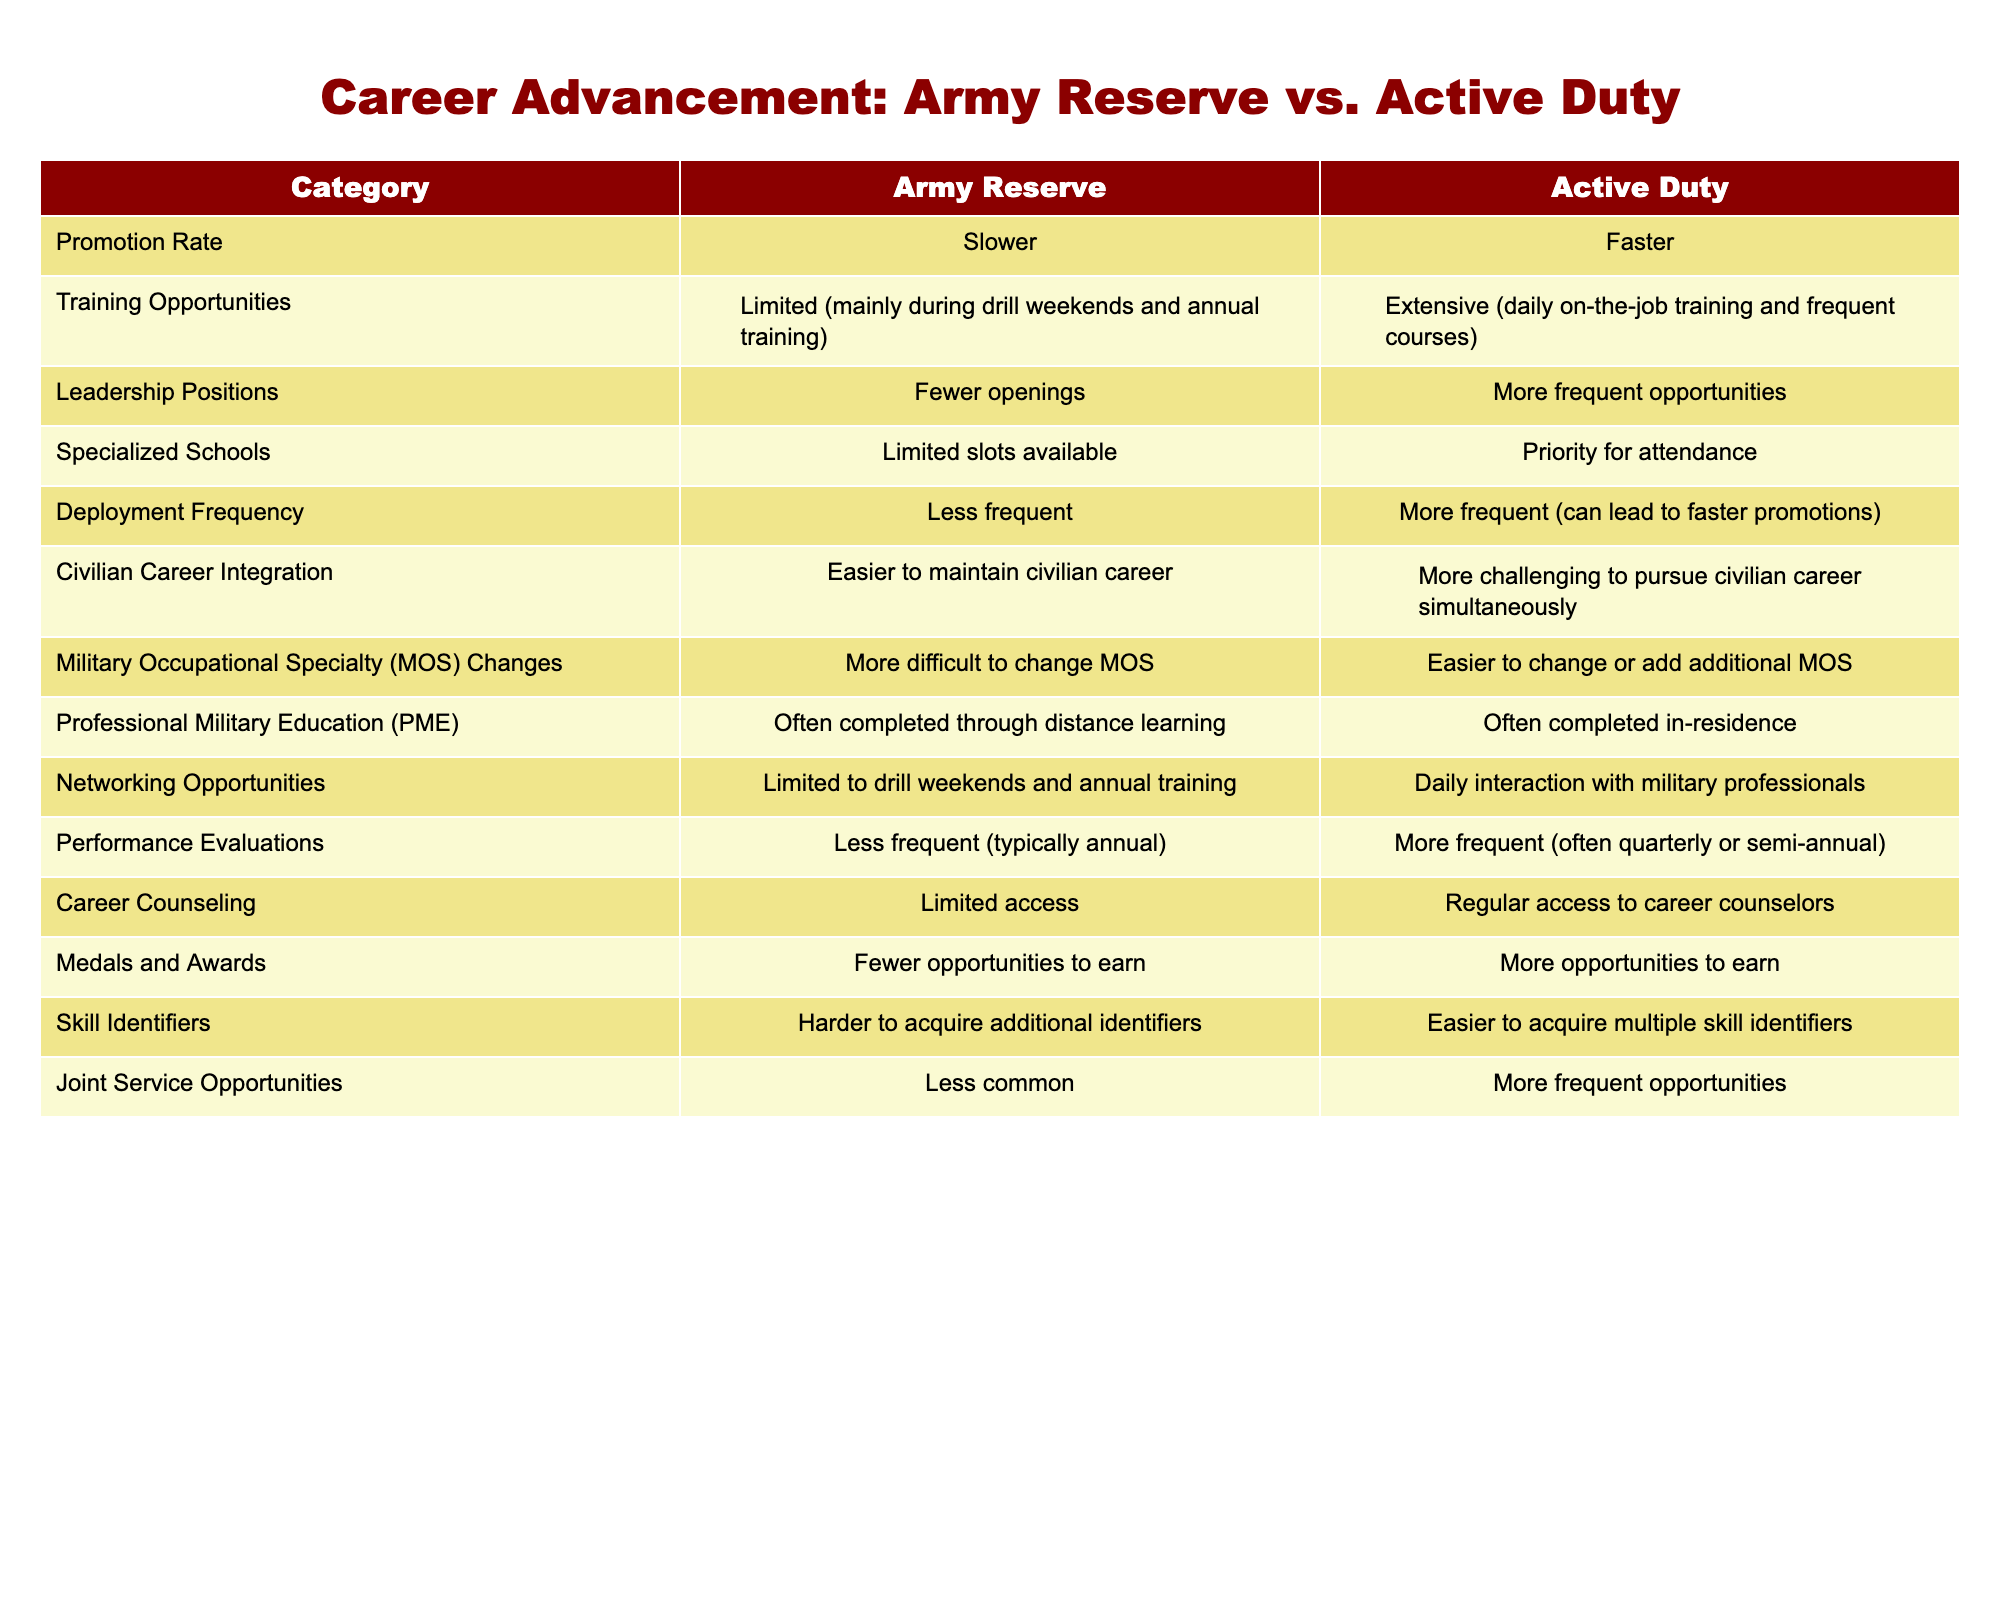What's the promotion rate for active duty personnel? According to the table, the promotion rate for active duty personnel is stated as "Faster."
Answer: Faster Are there more leadership positions available for active duty personnel than for army reserve members? The table indicates that there are "More frequent opportunities" for leadership positions in active duty compared to "Fewer openings" in the army reserve.
Answer: Yes How does the training opportunity differ between army reserves and active duty? The table states that the army reserve has "Limited (mainly during drill weekends and annual training)" training opportunities, while active duty members have "Extensive (daily on-the-job training and frequent courses)."
Answer: Active duty has extensive training opportunities What is the difference in deployment frequency between army reserve members and active duty personnel? The table shows that deployment frequency for army reserve members is "Less frequent," whereas for active duty personnel, it is "More frequent (can lead to faster promotions)." Thus, there is a clear difference in deployment frequency.
Answer: Less frequent for army reserves, more frequent for active duty On average, how often do performance evaluations occur for army reserve members compared to active duty personnel? For army reserve members, performance evaluations are "Less frequent (typically annual)," while for active duty personnel, they are "More frequent (often quarterly or semi-annual)." If we average, we see that active duty evaluations occur approximately three to six times a year, while army reserves do it once a year.
Answer: More frequent for active duty Are army reserve members more likely to receive medals and awards compared to active duty personnel? The information in the table explicitly states that army reserve members have "Fewer opportunities to earn," while active duty personnel have "More opportunities to earn." This indicates that active duty personnel are more likely to receive medals and awards.
Answer: No What unique challenges do army reserve members face in civilian career integration compared to active duty members? The table suggests that army reserve members find "Easier to maintain civilian career," whereas active duty personnel face "More challenging to pursue civilian career simultaneously." Thus, army reserve members have fewer challenges in integrating their military career with civilian life.
Answer: Easier for army reserve members How many more skill identifiers can active duty personnel acquire compared to army reserve members? According to the table, active duty personnel have "Easier to acquire multiple skill identifiers," while army reserve members find it "Harder to acquire additional identifiers." This suggests a relative ease in acquiring skill identifiers for active duty over reservists, but the exact number is not provided in the data.
Answer: More skill identifiers for active duty What can be concluded about the networking opportunities for active duty personnel versus those in the army reserve? The table indicates that networking opportunities for army reserve members are "Limited to drill weekends and annual training," but for active duty personnel, they have "Daily interaction with military professionals." This suggests that active duty personnel have significantly more networking opportunities.
Answer: Active duty personnel have more networking opportunities 